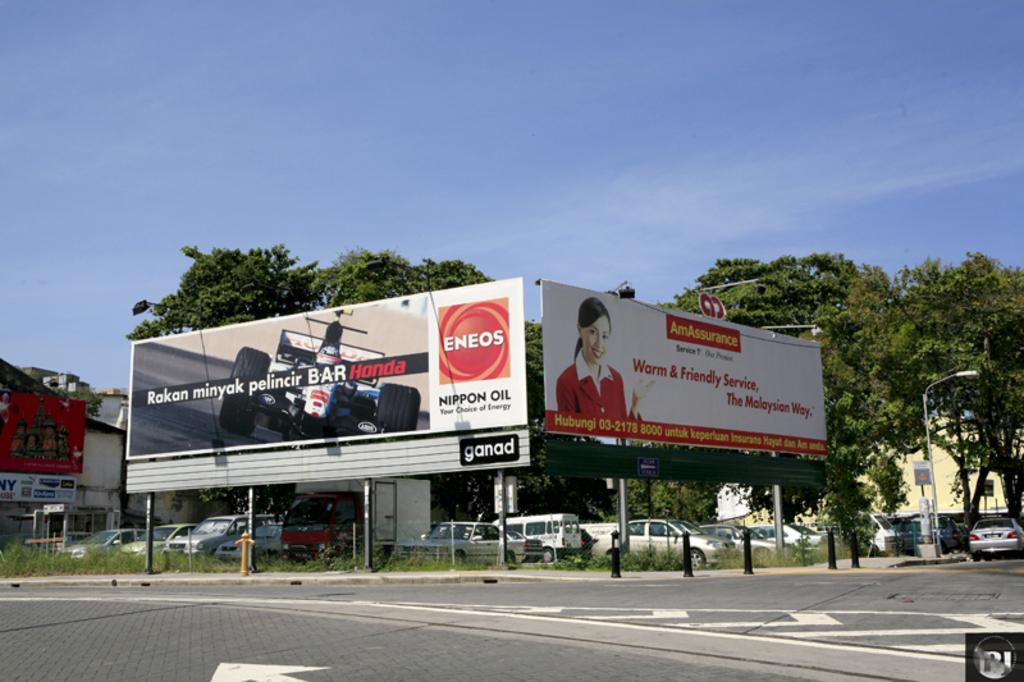<image>
Create a compact narrative representing the image presented. Two billboards facing the street, one for Honda and one for Am Assurance. 